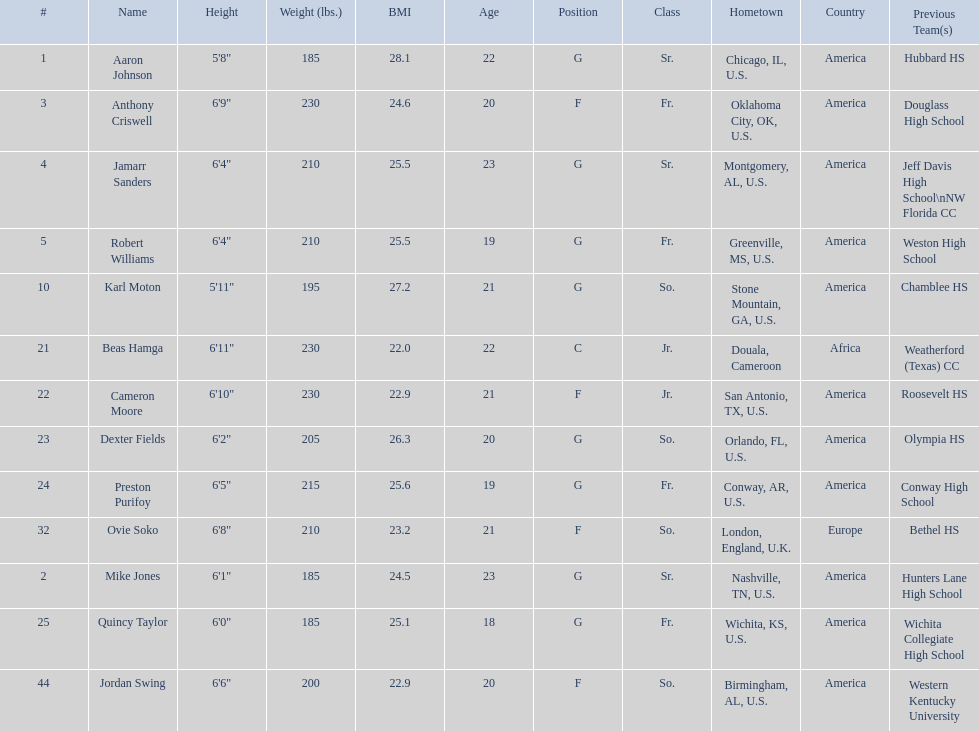Which are all of the players? Aaron Johnson, Anthony Criswell, Jamarr Sanders, Robert Williams, Karl Moton, Beas Hamga, Cameron Moore, Dexter Fields, Preston Purifoy, Ovie Soko, Mike Jones, Quincy Taylor, Jordan Swing. Which players are from a country outside of the u.s.? Beas Hamga, Ovie Soko. Aside from soko, who else is not from the u.s.? Beas Hamga. 